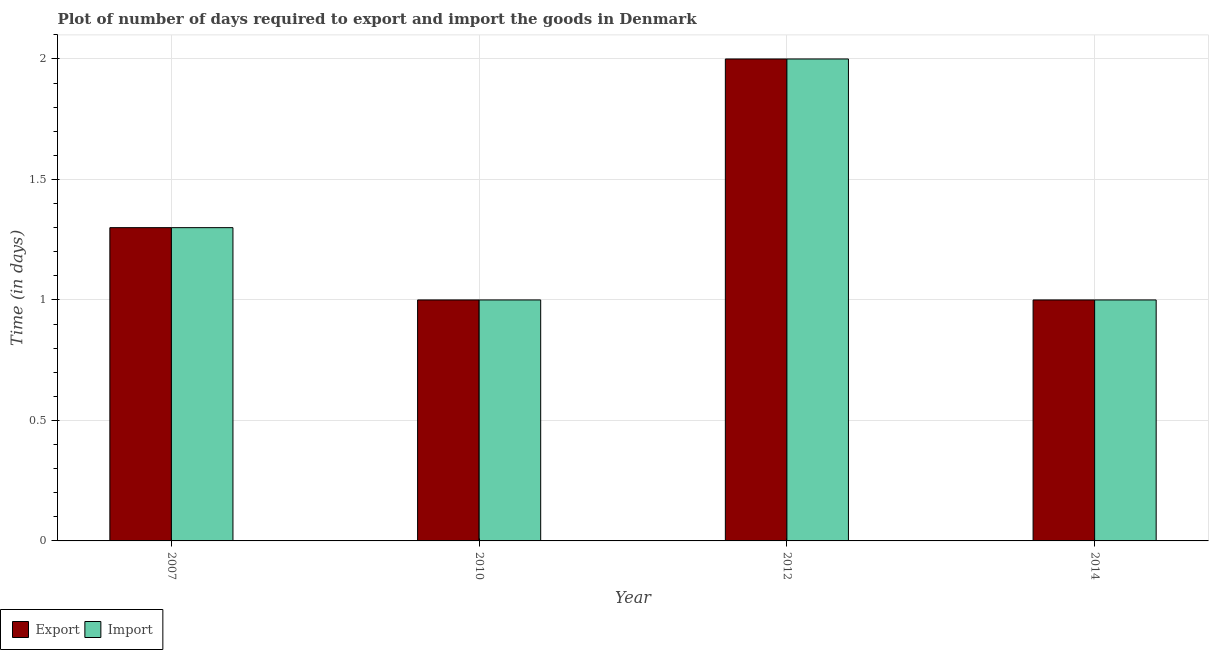How many different coloured bars are there?
Offer a terse response. 2. How many groups of bars are there?
Your response must be concise. 4. Are the number of bars on each tick of the X-axis equal?
Make the answer very short. Yes. How many bars are there on the 1st tick from the left?
Offer a terse response. 2. What is the label of the 3rd group of bars from the left?
Provide a short and direct response. 2012. In which year was the time required to import minimum?
Keep it short and to the point. 2010. What is the total time required to export in the graph?
Provide a succinct answer. 5.3. What is the difference between the time required to export in 2010 and the time required to import in 2007?
Your answer should be very brief. -0.3. What is the average time required to export per year?
Your answer should be compact. 1.32. What is the difference between the highest and the second highest time required to export?
Ensure brevity in your answer.  0.7. What is the difference between the highest and the lowest time required to import?
Provide a short and direct response. 1. In how many years, is the time required to export greater than the average time required to export taken over all years?
Your response must be concise. 1. What does the 2nd bar from the left in 2007 represents?
Keep it short and to the point. Import. What does the 2nd bar from the right in 2014 represents?
Provide a short and direct response. Export. Does the graph contain grids?
Make the answer very short. Yes. Where does the legend appear in the graph?
Give a very brief answer. Bottom left. What is the title of the graph?
Ensure brevity in your answer.  Plot of number of days required to export and import the goods in Denmark. What is the label or title of the Y-axis?
Ensure brevity in your answer.  Time (in days). What is the Time (in days) in Export in 2010?
Offer a terse response. 1. What is the Time (in days) in Import in 2014?
Give a very brief answer. 1. Across all years, what is the minimum Time (in days) of Import?
Your response must be concise. 1. What is the difference between the Time (in days) of Export in 2007 and that in 2012?
Your response must be concise. -0.7. What is the difference between the Time (in days) of Export in 2010 and that in 2012?
Offer a very short reply. -1. What is the difference between the Time (in days) in Import in 2010 and that in 2012?
Ensure brevity in your answer.  -1. What is the difference between the Time (in days) of Export in 2010 and that in 2014?
Your response must be concise. 0. What is the difference between the Time (in days) in Export in 2012 and that in 2014?
Make the answer very short. 1. What is the difference between the Time (in days) in Export in 2010 and the Time (in days) in Import in 2012?
Make the answer very short. -1. What is the difference between the Time (in days) in Export in 2012 and the Time (in days) in Import in 2014?
Keep it short and to the point. 1. What is the average Time (in days) of Export per year?
Provide a succinct answer. 1.32. What is the average Time (in days) in Import per year?
Keep it short and to the point. 1.32. What is the ratio of the Time (in days) of Export in 2007 to that in 2010?
Ensure brevity in your answer.  1.3. What is the ratio of the Time (in days) in Export in 2007 to that in 2012?
Offer a very short reply. 0.65. What is the ratio of the Time (in days) of Import in 2007 to that in 2012?
Make the answer very short. 0.65. What is the ratio of the Time (in days) of Export in 2007 to that in 2014?
Make the answer very short. 1.3. What is the ratio of the Time (in days) in Export in 2012 to that in 2014?
Your answer should be compact. 2. What is the ratio of the Time (in days) of Import in 2012 to that in 2014?
Offer a very short reply. 2. What is the difference between the highest and the second highest Time (in days) in Export?
Your answer should be very brief. 0.7. What is the difference between the highest and the second highest Time (in days) in Import?
Offer a very short reply. 0.7. What is the difference between the highest and the lowest Time (in days) of Import?
Keep it short and to the point. 1. 